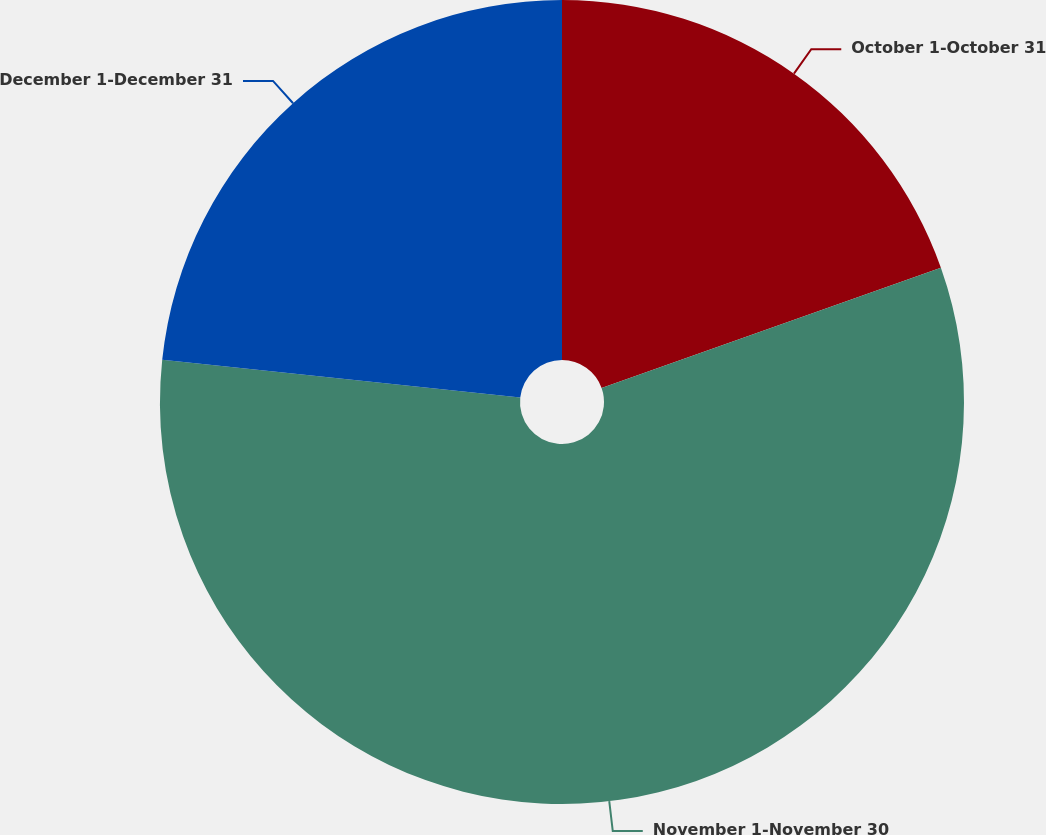<chart> <loc_0><loc_0><loc_500><loc_500><pie_chart><fcel>October 1-October 31<fcel>November 1-November 30<fcel>December 1-December 31<nl><fcel>19.58%<fcel>57.1%<fcel>23.33%<nl></chart> 